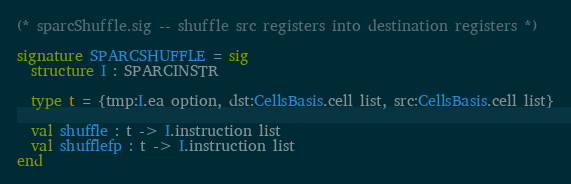Convert code to text. <code><loc_0><loc_0><loc_500><loc_500><_SML_>(* sparcShuffle.sig -- shuffle src registers into destination registers *)

signature SPARCSHUFFLE = sig
  structure I : SPARCINSTR
 
  type t = {tmp:I.ea option, dst:CellsBasis.cell list, src:CellsBasis.cell list}

  val shuffle : t -> I.instruction list
  val shufflefp : t -> I.instruction list
end

</code> 